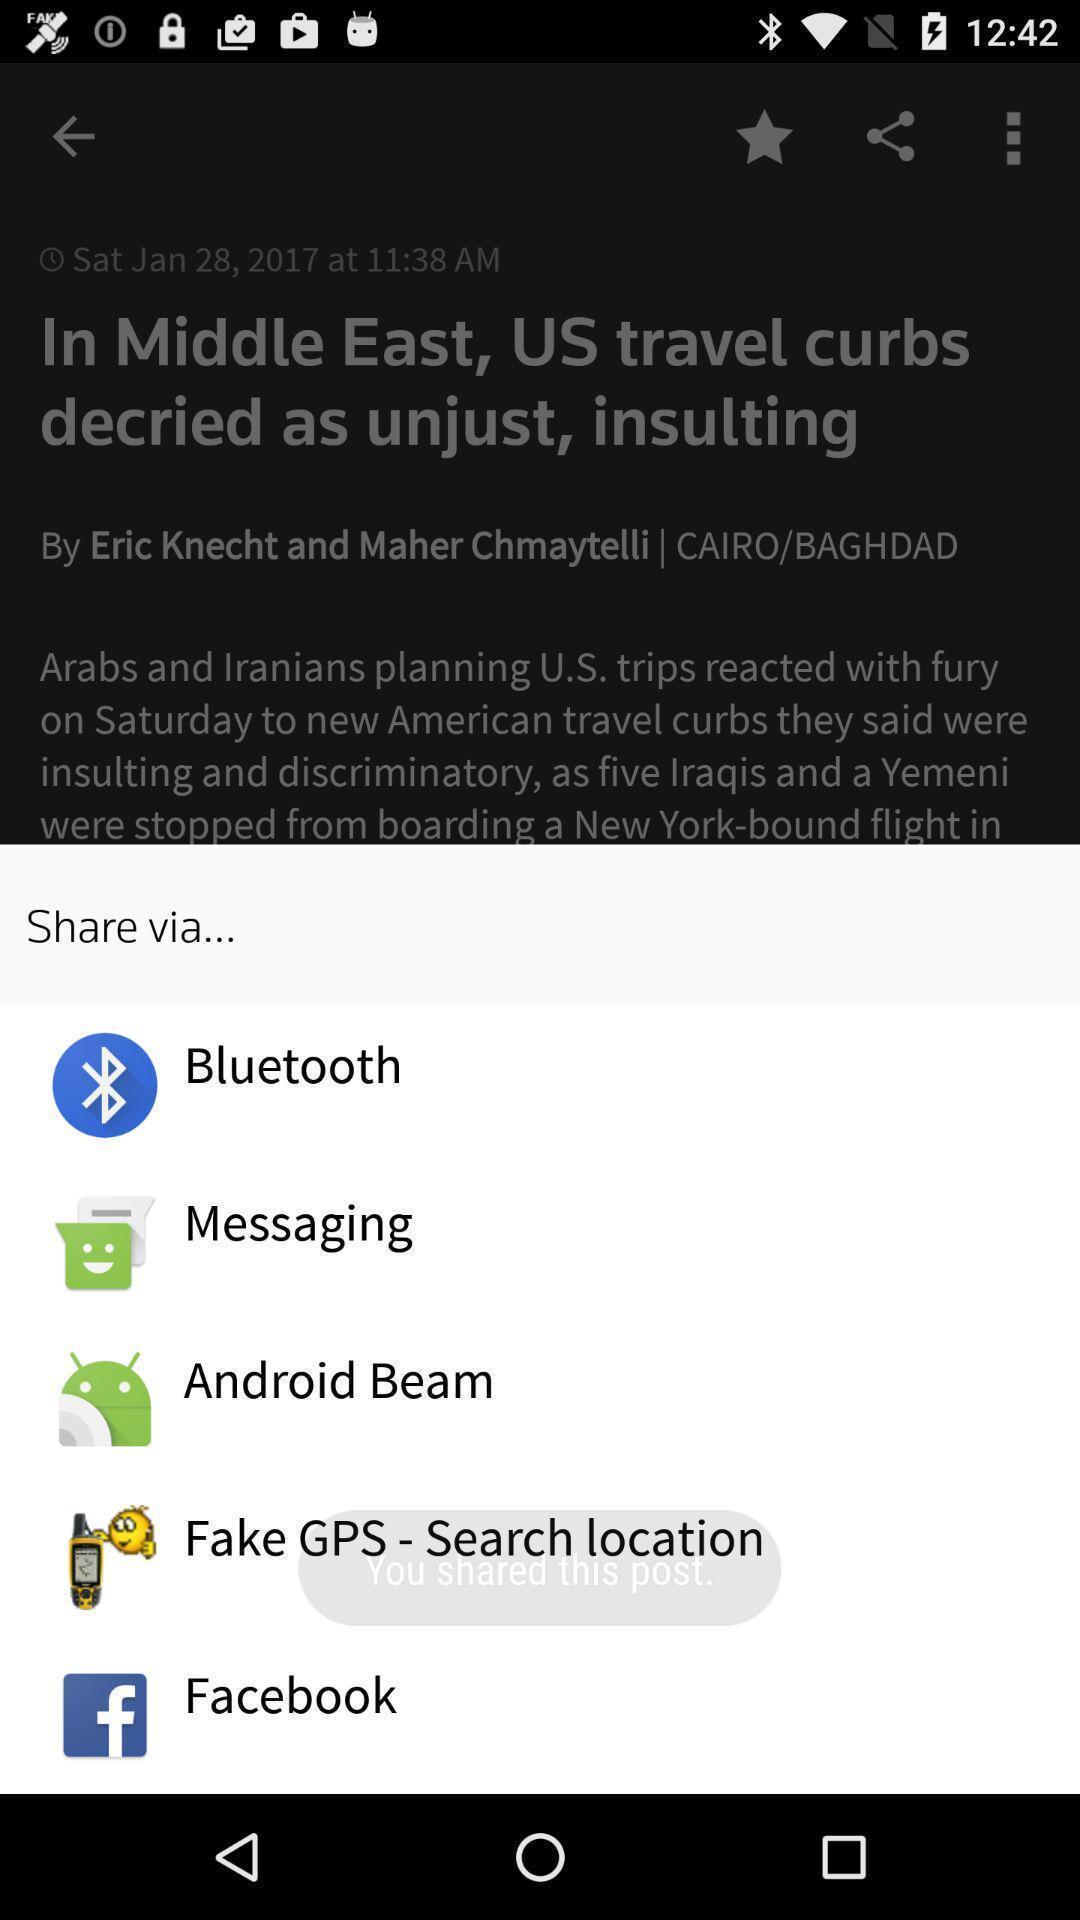Tell me what you see in this picture. Push up showing list of social apps. 